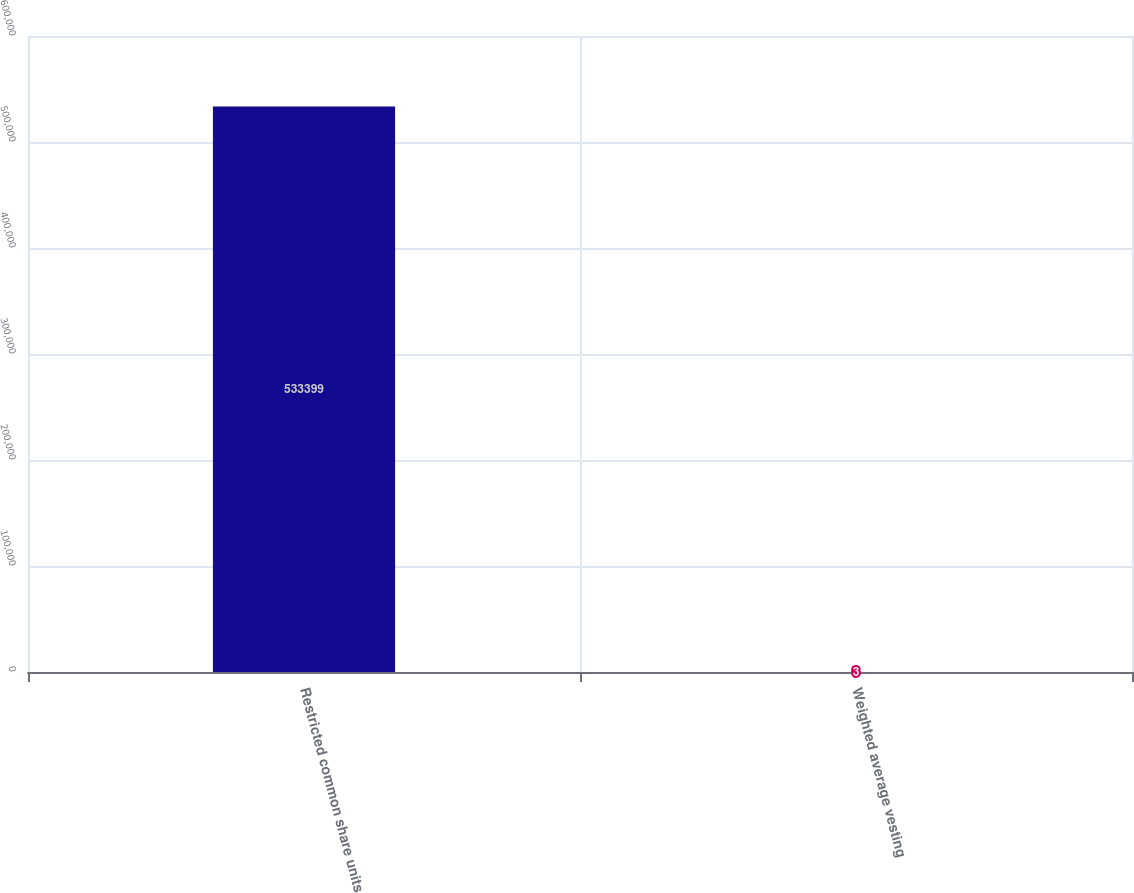<chart> <loc_0><loc_0><loc_500><loc_500><bar_chart><fcel>Restricted common share units<fcel>Weighted average vesting<nl><fcel>533399<fcel>3<nl></chart> 